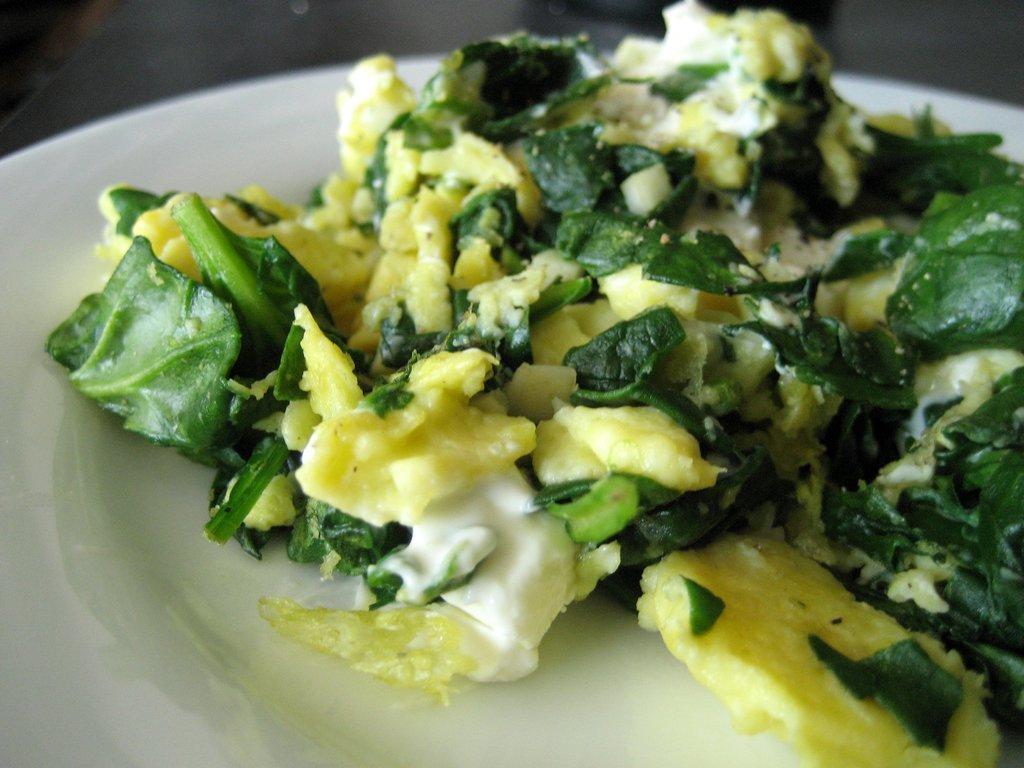How would you summarize this image in a sentence or two? In this image, we can see a food item in the plate, placed on the table. 